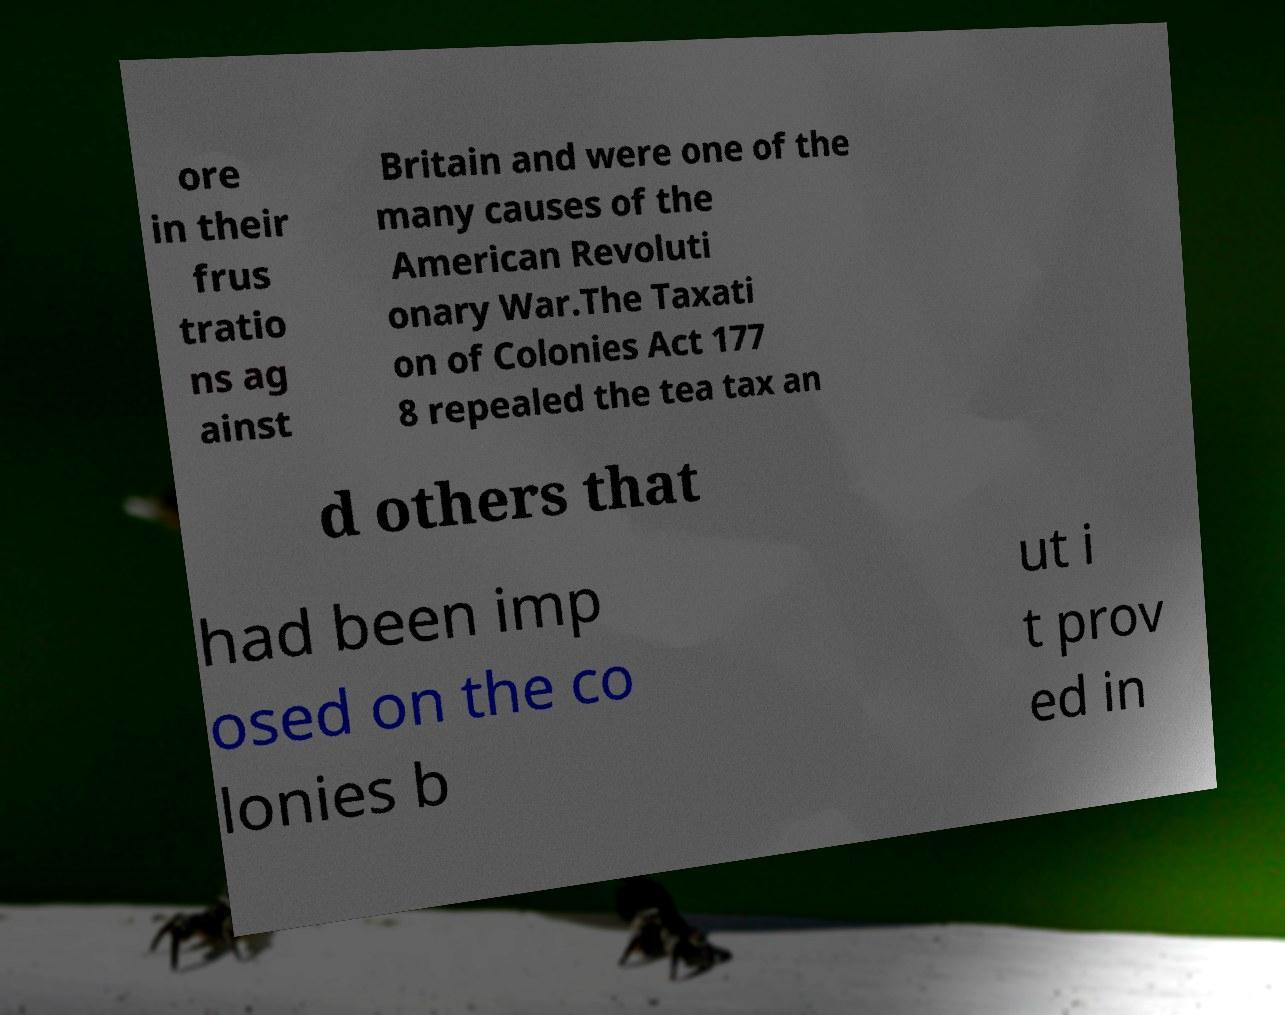Could you extract and type out the text from this image? ore in their frus tratio ns ag ainst Britain and were one of the many causes of the American Revoluti onary War.The Taxati on of Colonies Act 177 8 repealed the tea tax an d others that had been imp osed on the co lonies b ut i t prov ed in 